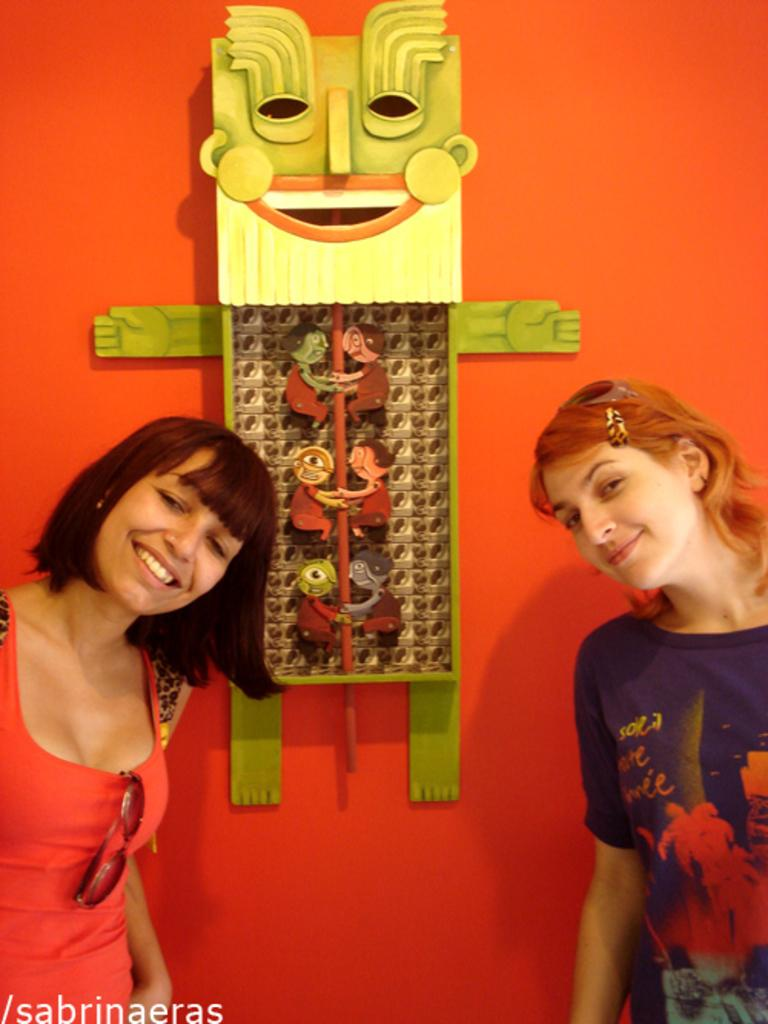How many women are present in the image? There are women on both the right and left sides of the image, so there are at least two women present. What can be seen in the background of the image? There is a wall hanging and a wall in the background of the image. Where is the nest of the insect in the image? There is no nest or insect present in the image. 